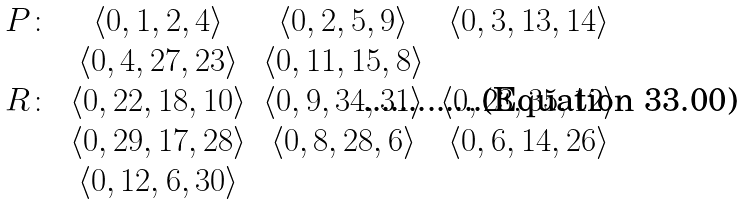Convert formula to latex. <formula><loc_0><loc_0><loc_500><loc_500>\begin{array} { c c c c } P \colon & \langle 0 , 1 , 2 , 4 \rangle & \langle 0 , 2 , 5 , 9 \rangle & \langle 0 , 3 , 1 3 , 1 4 \rangle \\ & \langle 0 , 4 , 2 7 , 2 3 \rangle & \langle 0 , 1 1 , 1 5 , 8 \rangle \\ R \colon & \langle 0 , 2 2 , 1 8 , 1 0 \rangle & \langle 0 , 9 , 3 4 , 3 1 \rangle & \langle 0 , 2 3 , 3 5 , 1 2 \rangle \\ & \langle 0 , 2 9 , 1 7 , 2 8 \rangle & \langle 0 , 8 , 2 8 , 6 \rangle & \langle 0 , 6 , 1 4 , 2 6 \rangle \\ & \langle 0 , 1 2 , 6 , 3 0 \rangle \\ \end{array}</formula> 